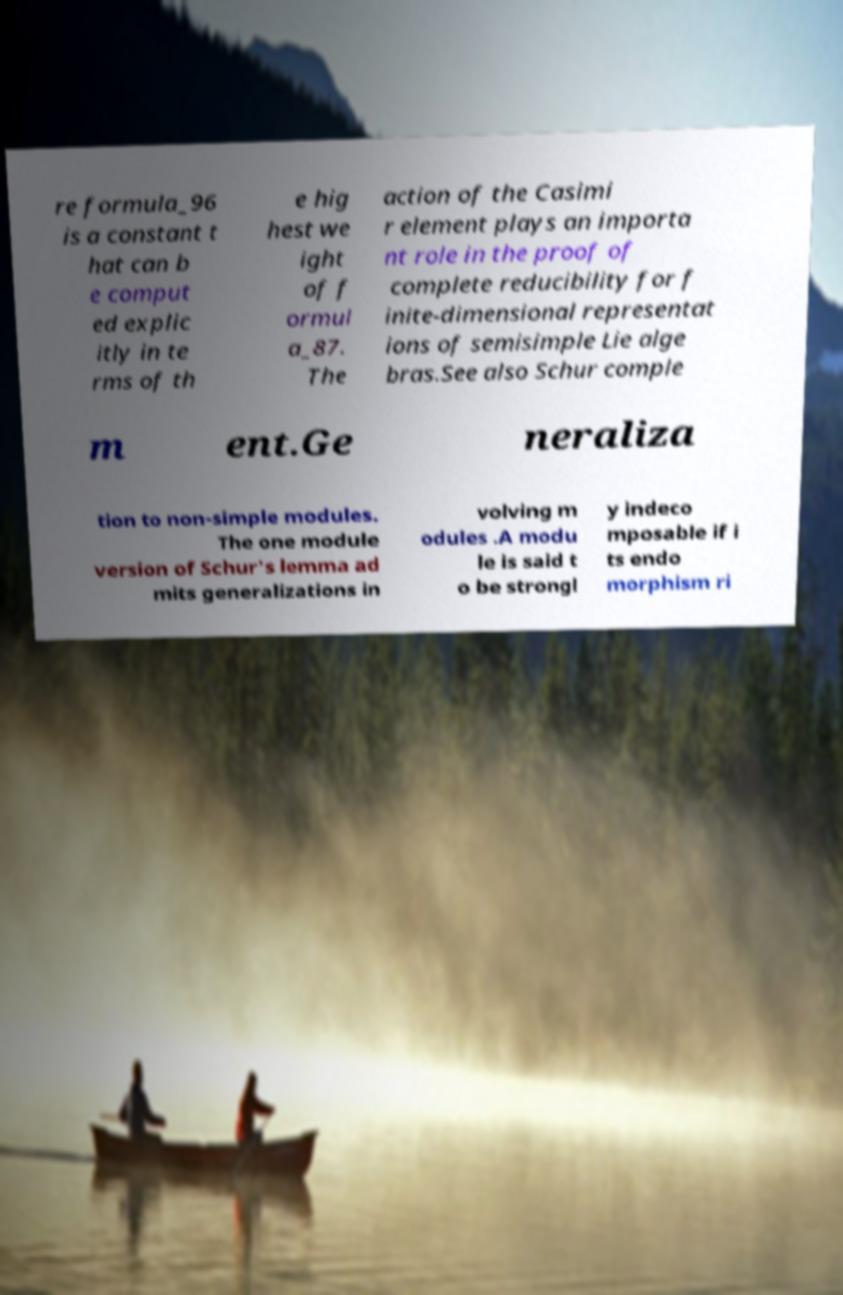For documentation purposes, I need the text within this image transcribed. Could you provide that? re formula_96 is a constant t hat can b e comput ed explic itly in te rms of th e hig hest we ight of f ormul a_87. The action of the Casimi r element plays an importa nt role in the proof of complete reducibility for f inite-dimensional representat ions of semisimple Lie alge bras.See also Schur comple m ent.Ge neraliza tion to non-simple modules. The one module version of Schur's lemma ad mits generalizations in volving m odules .A modu le is said t o be strongl y indeco mposable if i ts endo morphism ri 